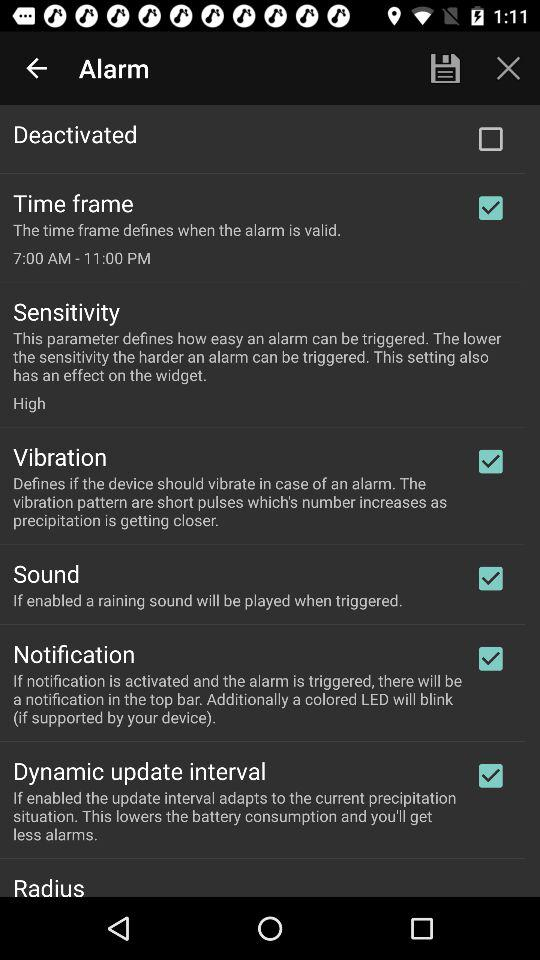What is the status of "Vibration"? The status is "on". 